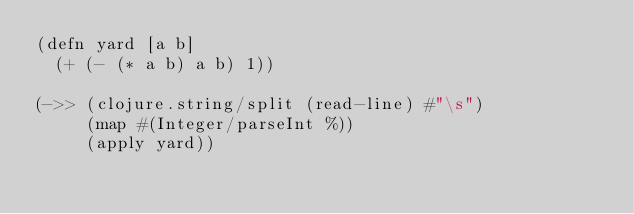<code> <loc_0><loc_0><loc_500><loc_500><_Clojure_>(defn yard [a b]
  (+ (- (* a b) a b) 1))

(->> (clojure.string/split (read-line) #"\s")
     (map #(Integer/parseInt %))
     (apply yard))</code> 